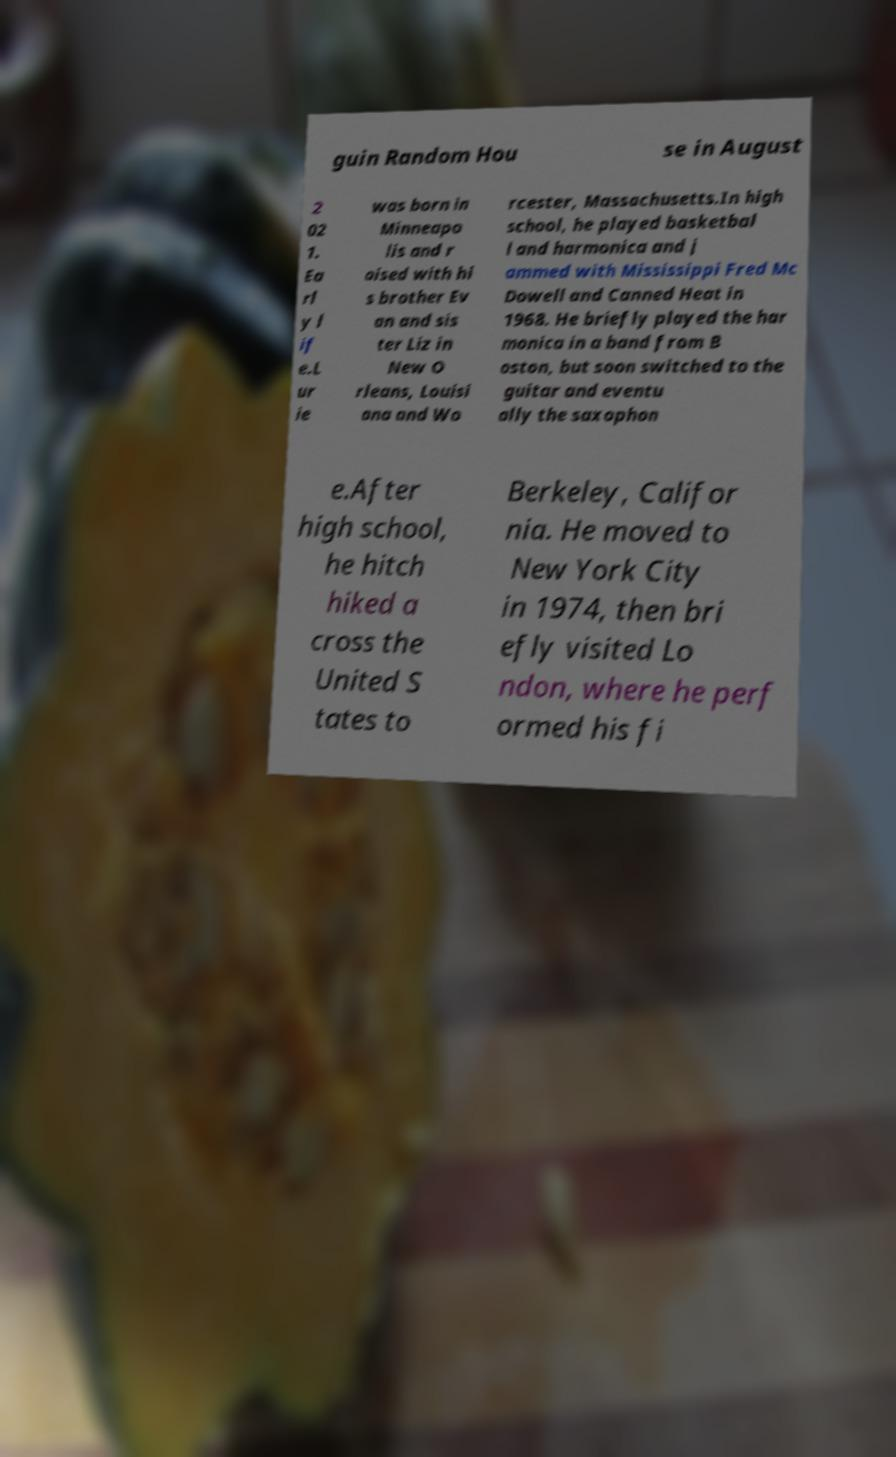Can you read and provide the text displayed in the image?This photo seems to have some interesting text. Can you extract and type it out for me? guin Random Hou se in August 2 02 1. Ea rl y l if e.L ur ie was born in Minneapo lis and r aised with hi s brother Ev an and sis ter Liz in New O rleans, Louisi ana and Wo rcester, Massachusetts.In high school, he played basketbal l and harmonica and j ammed with Mississippi Fred Mc Dowell and Canned Heat in 1968. He briefly played the har monica in a band from B oston, but soon switched to the guitar and eventu ally the saxophon e.After high school, he hitch hiked a cross the United S tates to Berkeley, Califor nia. He moved to New York City in 1974, then bri efly visited Lo ndon, where he perf ormed his fi 